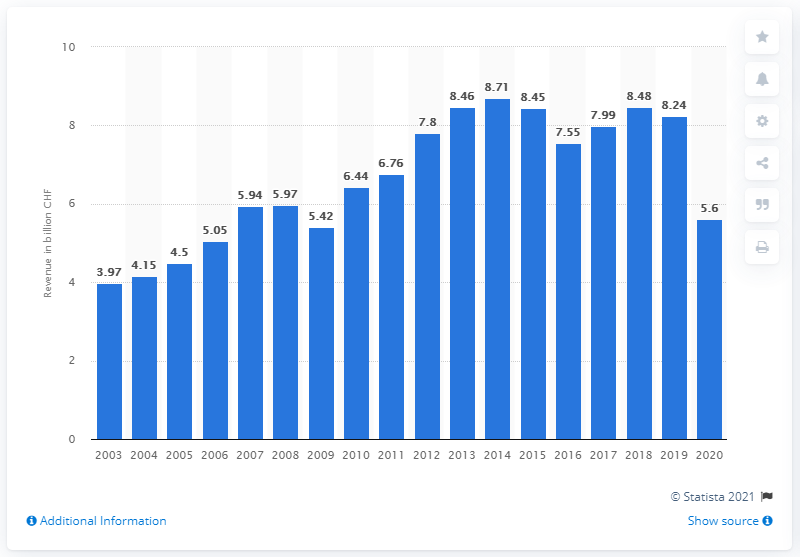Mention a couple of crucial points in this snapshot. In 2020, the Swatch Group reported global revenues of approximately 5.6 billion U.S. dollars. 